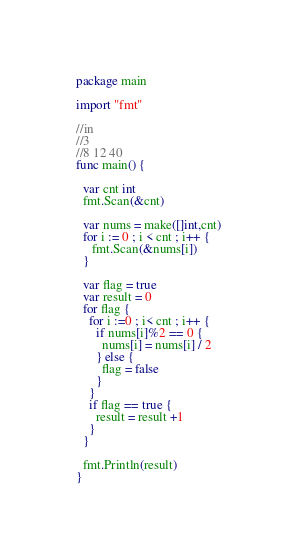Convert code to text. <code><loc_0><loc_0><loc_500><loc_500><_Go_>package main

import "fmt"

//in
//3
//8 12 40
func main() {

  var cnt int
  fmt.Scan(&cnt)

  var nums = make([]int,cnt)
  for i := 0 ; i < cnt ; i++ {
     fmt.Scan(&nums[i])
  }
  
  var flag = true
  var result = 0
  for flag {
    for i :=0 ; i< cnt ; i++ {
      if nums[i]%2 == 0 {
        nums[i] = nums[i] / 2
      } else {
      	flag = false
      }
    }
    if flag == true {
      result = result +1 
    }
  }
  
  fmt.Println(result)
}

</code> 